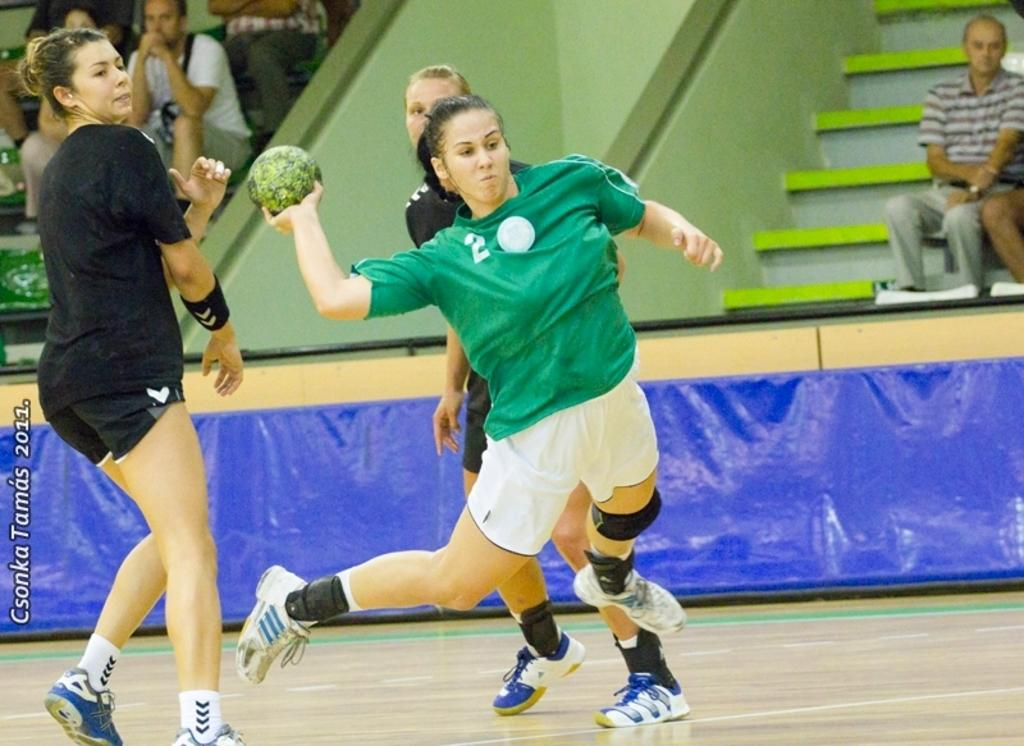What activity is taking place in the image? There are players playing on a court in the image. What can be seen in the background of the image? There are people sitting on benches in the background of the image. Where is the text located in the image? The text is in the bottom left corner of the image. What is the name of the person who died during the game in the image? There is no indication of a death or a person's name in the image; it simply shows players playing on a court and people sitting on benches in the background. 